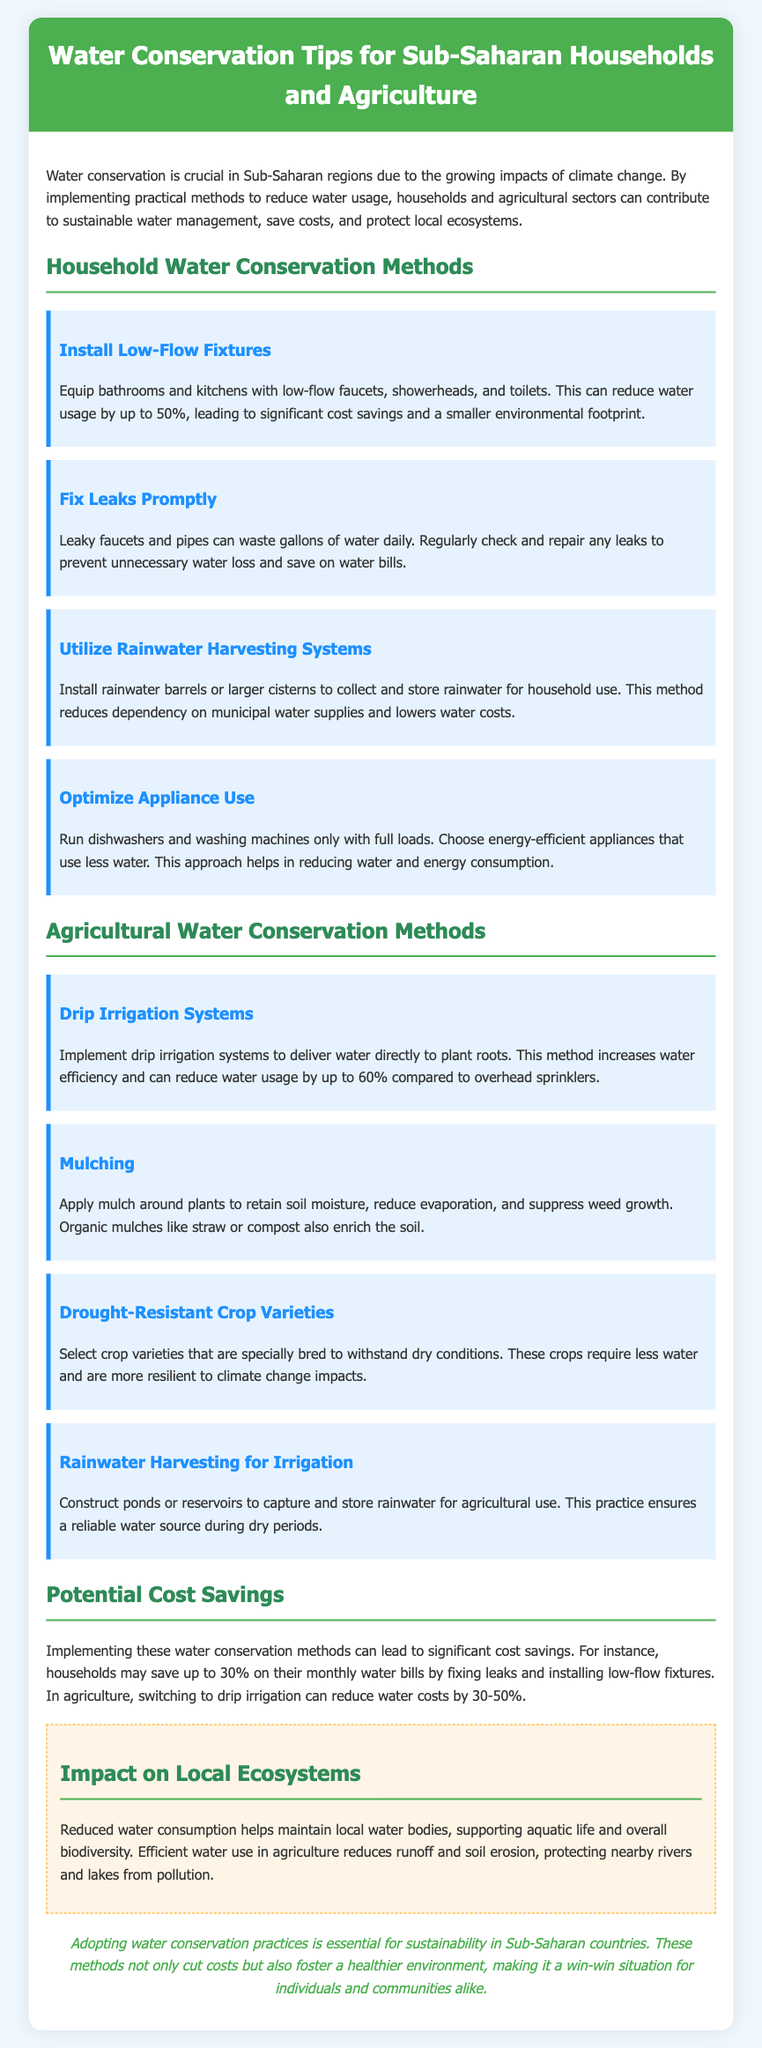what is the title of the document? The title is found in the header section of the document.
Answer: Water Conservation Tips for Sub-Saharan Regions how much can low-flow fixtures reduce water usage? This information is provided in the description of low-flow fixtures.
Answer: up to 50% what method helps to prevent unnecessary water loss? The method that addresses this issue is detailed under household conservation methods.
Answer: Fix Leaks Promptly what percentage of water cost reduction can drip irrigation achieve? The percentage is mentioned in the description of drip irrigation systems.
Answer: up to 60% what is one potential cost saving for households from implementing water conservation methods? This information is found in the section detailing cost savings.
Answer: up to 30% which practice enriches the soil while reducing evaporation? This practice is highlighted in the agricultural methods section.
Answer: Mulching how do drought-resistant crop varieties help in water conservation? The reasoning behind their benefits is explained in the corresponding method description.
Answer: require less water what is the consequence of reduced water consumption on local ecosystems? This consequence is described in the impact assessment section.
Answer: supports aquatic life and overall biodiversity 